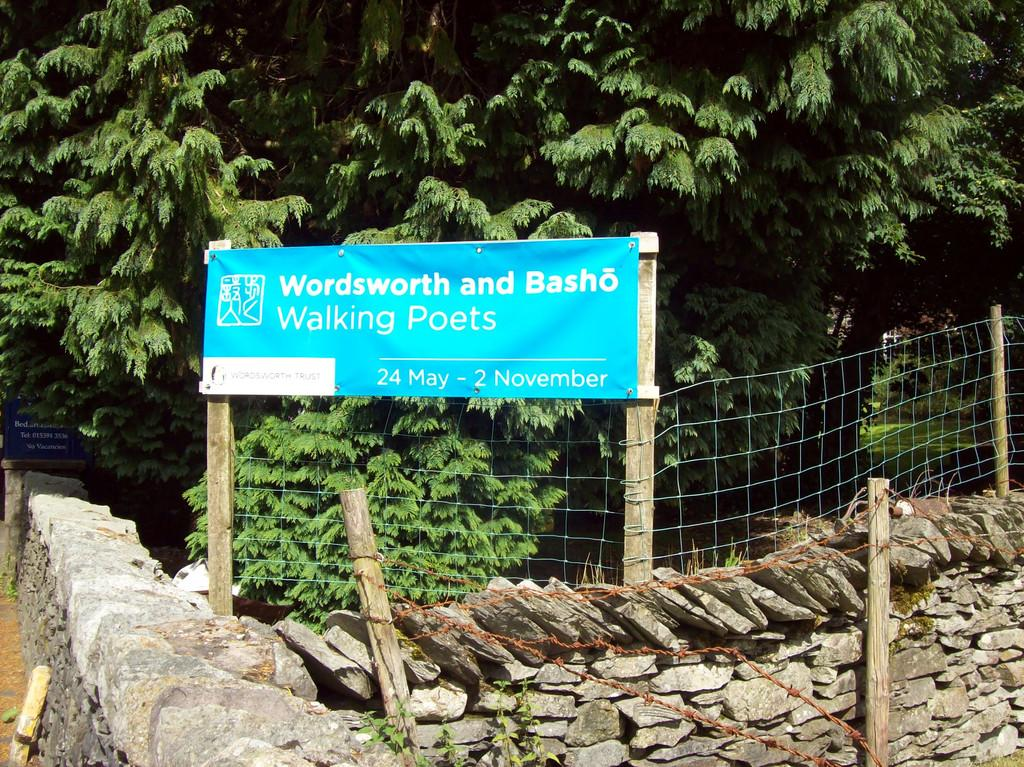What type of natural elements can be seen in the image? There are trees in the image. What type of man-made structures can be seen in the image? There is a fence, poles, a wall, and a banner in the image. What type of material is present in the image? There are stones in the image. What type of signage is present in the image? There is a board with information on the left side of the image. How does the self-attraction of the trees affect the crowd in the image? There is no mention of a crowd in the image, and trees do not have self-attraction. 